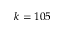<formula> <loc_0><loc_0><loc_500><loc_500>k = 1 0 5</formula> 